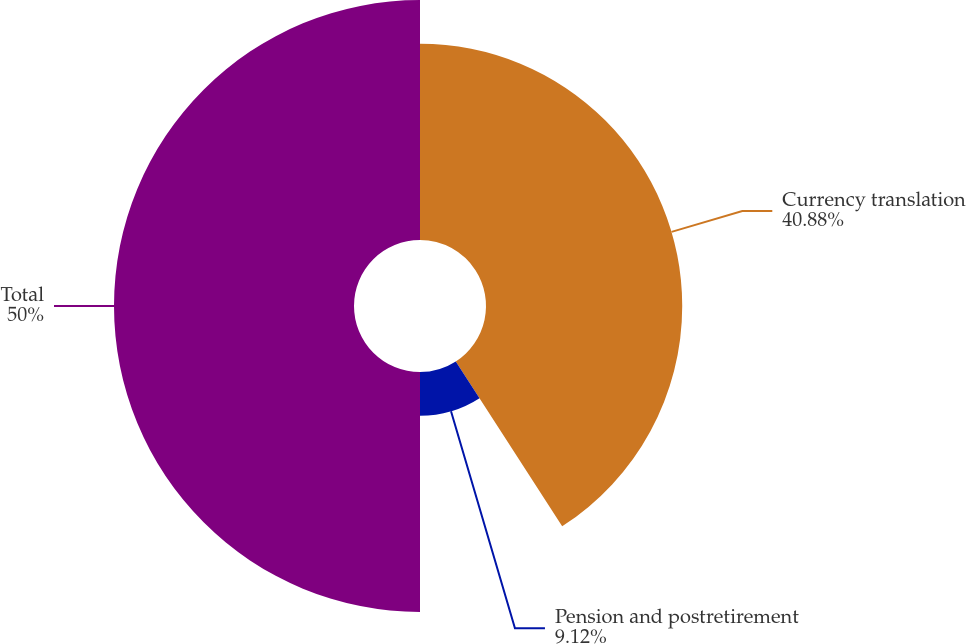Convert chart. <chart><loc_0><loc_0><loc_500><loc_500><pie_chart><fcel>Currency translation<fcel>Pension and postretirement<fcel>Total<nl><fcel>40.88%<fcel>9.12%<fcel>50.0%<nl></chart> 